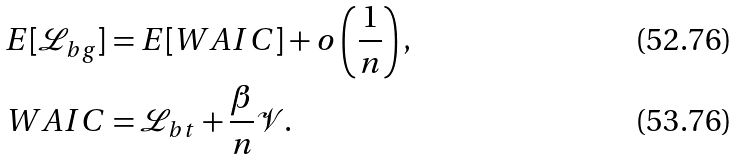<formula> <loc_0><loc_0><loc_500><loc_500>E [ \mathcal { L } _ { b g } ] & = E [ W A I C ] + o \left ( \frac { 1 } { n } \right ) , \\ W A I C & = \mathcal { L } _ { b t } + \frac { \beta } { n } \mathcal { V } .</formula> 